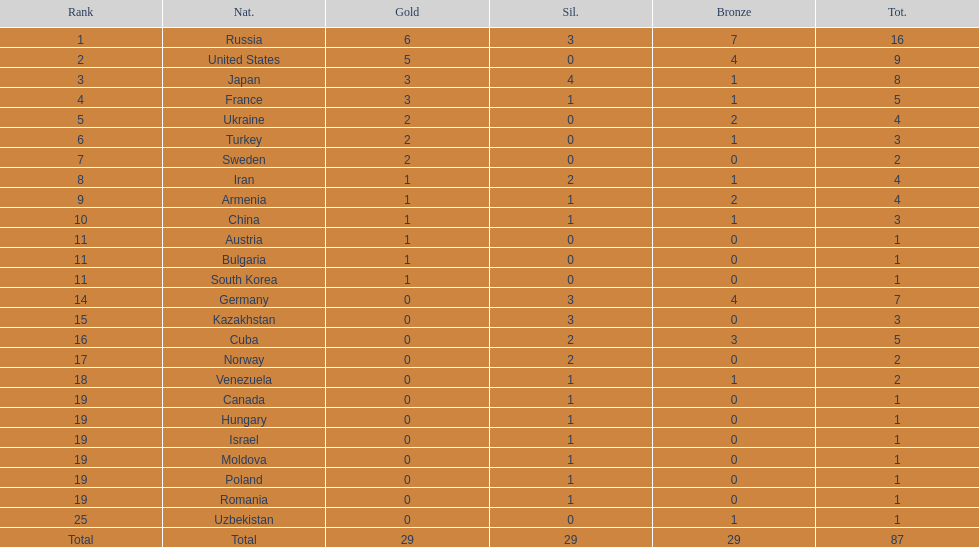Which country won only one medal, a bronze medal? Uzbekistan. 